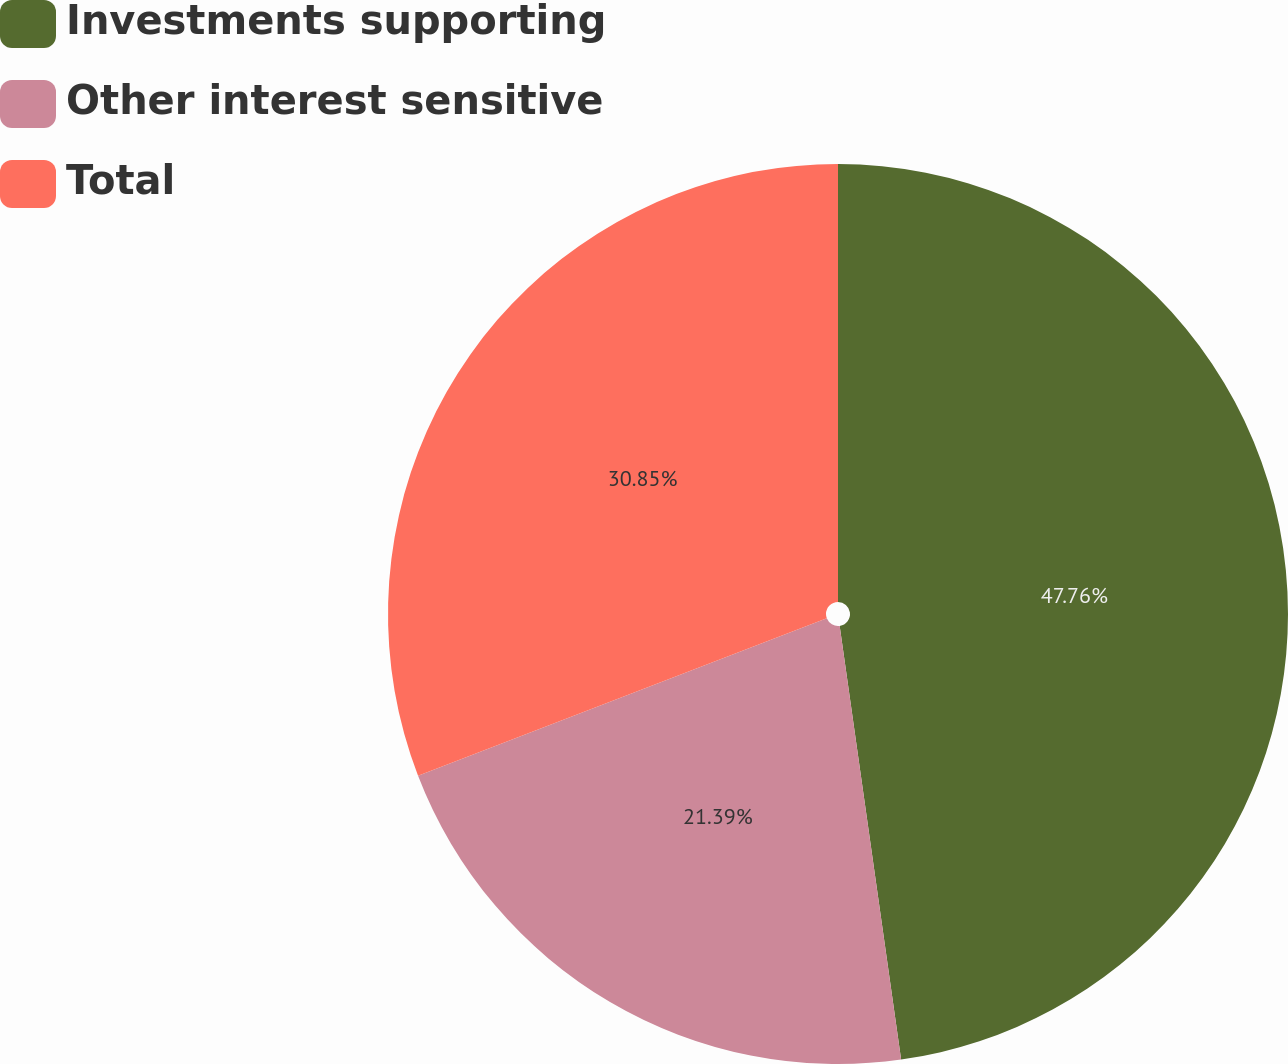Convert chart to OTSL. <chart><loc_0><loc_0><loc_500><loc_500><pie_chart><fcel>Investments supporting<fcel>Other interest sensitive<fcel>Total<nl><fcel>47.76%<fcel>21.39%<fcel>30.85%<nl></chart> 